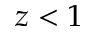Convert formula to latex. <formula><loc_0><loc_0><loc_500><loc_500>z < 1</formula> 